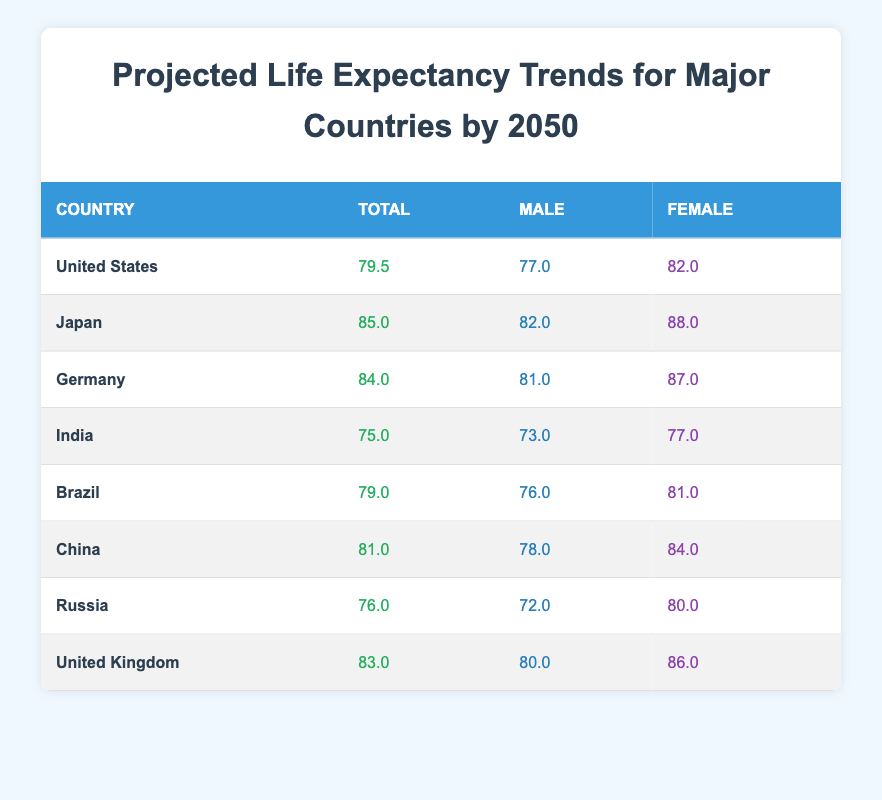What's the projected life expectancy for Japan? Referring to the table, Japan's projected life expectancy is stated clearly in the second row.
Answer: 85.0 Which country has the highest life expectancy for females? Looking through the female life expectancy values, Japan has the highest value at 88.0, which can be found in its corresponding row.
Answer: Japan What is the life expectancy difference between males and females in Germany? For Germany, the male life expectancy is 81.0 and the female life expectancy is 87.0. The difference is calculated by subtracting the male value from the female value: 87.0 - 81.0 = 6.0.
Answer: 6.0 Is the life expectancy for males in the United Kingdom higher than that in Russia? The table shows that the male life expectancy in the United Kingdom is 80.0, while in Russia it is 72.0. Since 80.0 is greater than 72.0, the answer is yes.
Answer: Yes If we average the projected life expectancy of China and Brazil, what will it be? The projected life expectancy for China is 81.0 and for Brazil, it is 79.0. To find the average, we add both values and divide by 2: (81.0 + 79.0) / 2 = 80.0.
Answer: 80.0 What is the lowest projected life expectancy among the countries listed? By scanning through all projected life expectancy values in the table, India has the lowest at 75.0, which is visible in its corresponding row.
Answer: 75.0 Does any country have a projected life expectancy of exactly 80.0? Checking all the life expectancy figures, none show exactly 80.0 as a projected value. Therefore, the answer is no.
Answer: No 